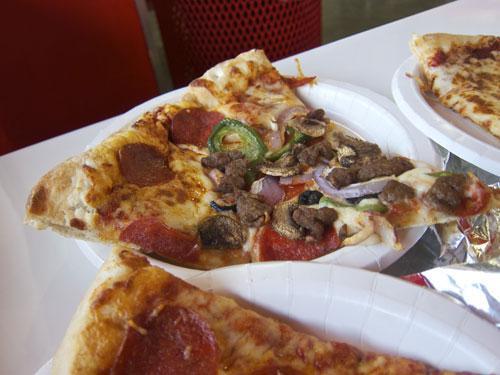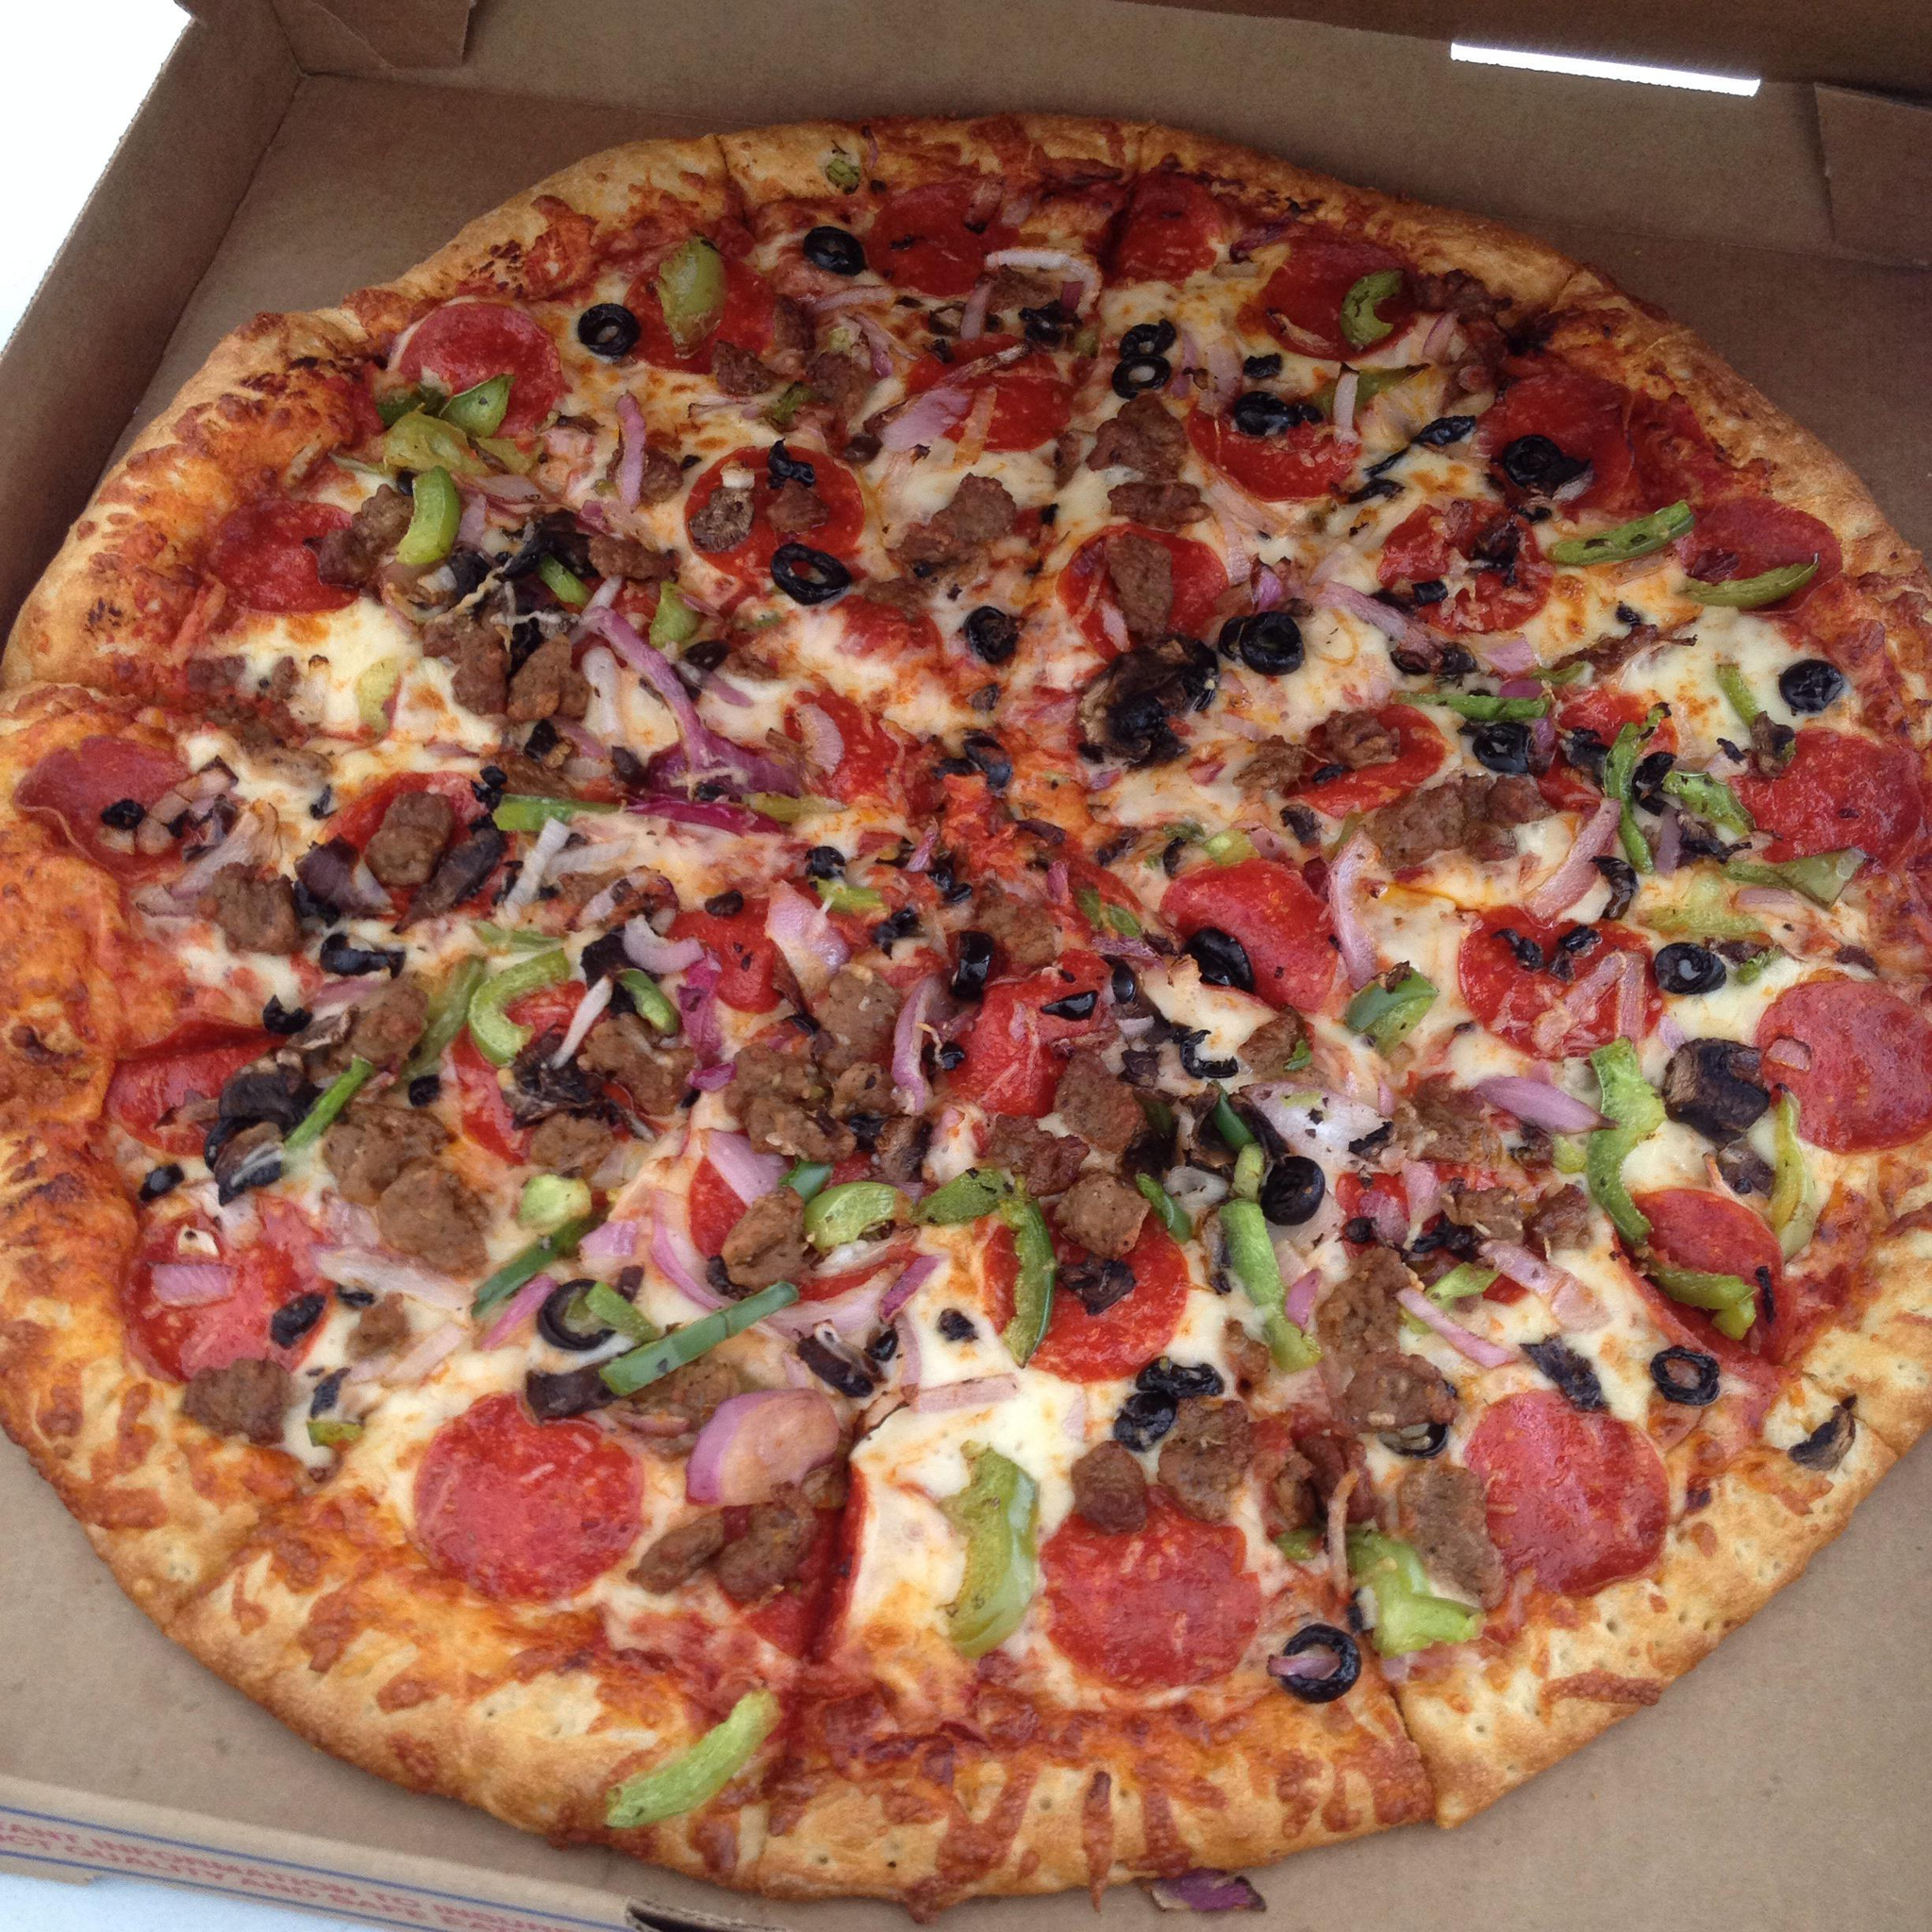The first image is the image on the left, the second image is the image on the right. Given the left and right images, does the statement "One image shows al least one pizza slice in a disposable plate and the other shows a full pizza in a brown cardboard box." hold true? Answer yes or no. Yes. The first image is the image on the left, the second image is the image on the right. Given the left and right images, does the statement "The right image shows a whole sliced pizza in an open box, and the left image shows a triangular slice of pizza on a small round white plate." hold true? Answer yes or no. Yes. 